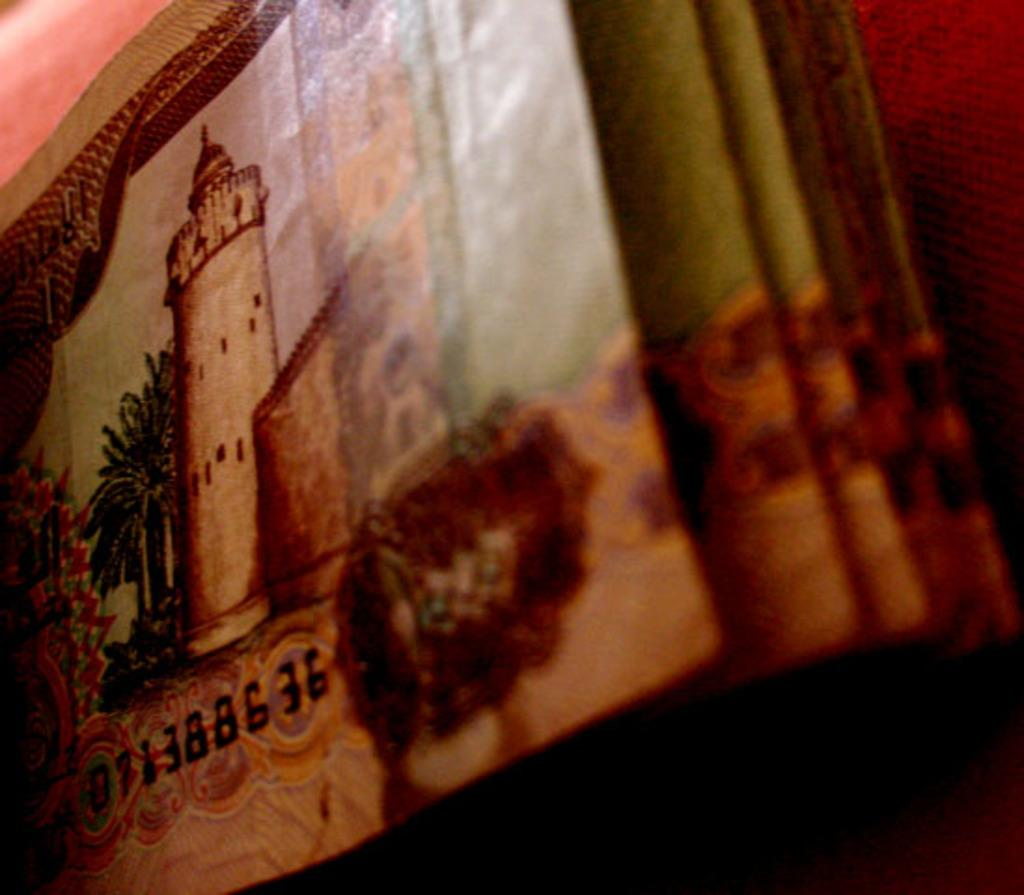<image>
Write a terse but informative summary of the picture. A stack of napkins with a lighthouse on them and the number 071388636. 